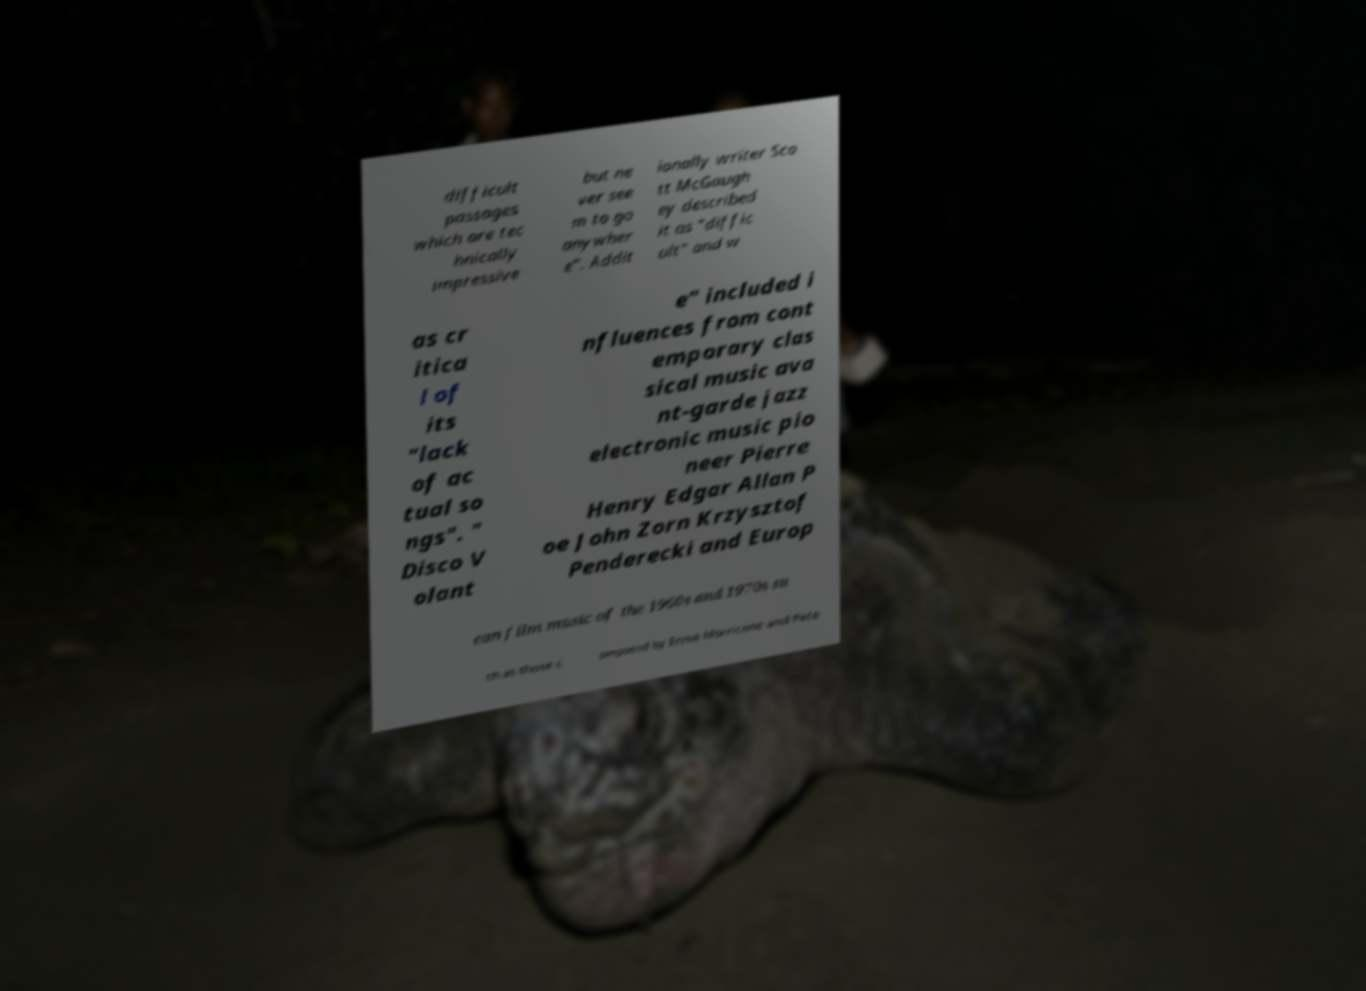Could you extract and type out the text from this image? difficult passages which are tec hnically impressive but ne ver see m to go anywher e". Addit ionally writer Sco tt McGaugh ey described it as "diffic ult" and w as cr itica l of its "lack of ac tual so ngs". " Disco V olant e" included i nfluences from cont emporary clas sical music ava nt-garde jazz electronic music pio neer Pierre Henry Edgar Allan P oe John Zorn Krzysztof Penderecki and Europ ean film music of the 1960s and 1970s su ch as those c omposed by Ennio Morricone and Pete 